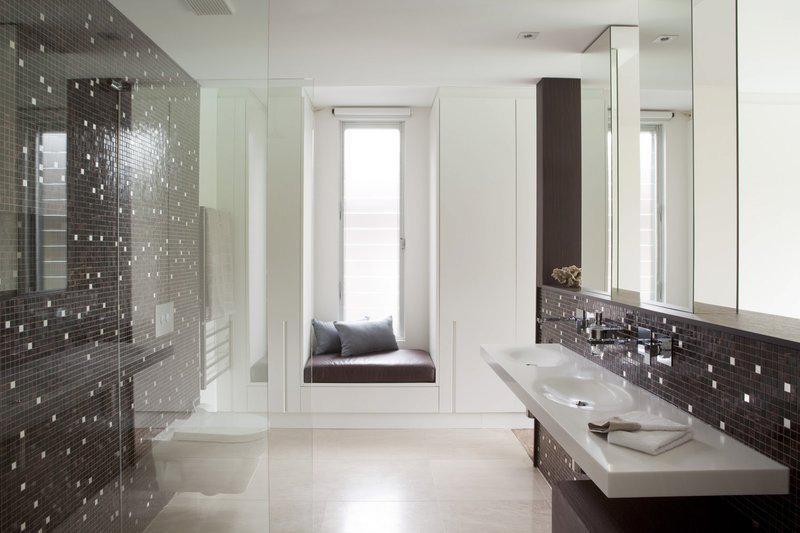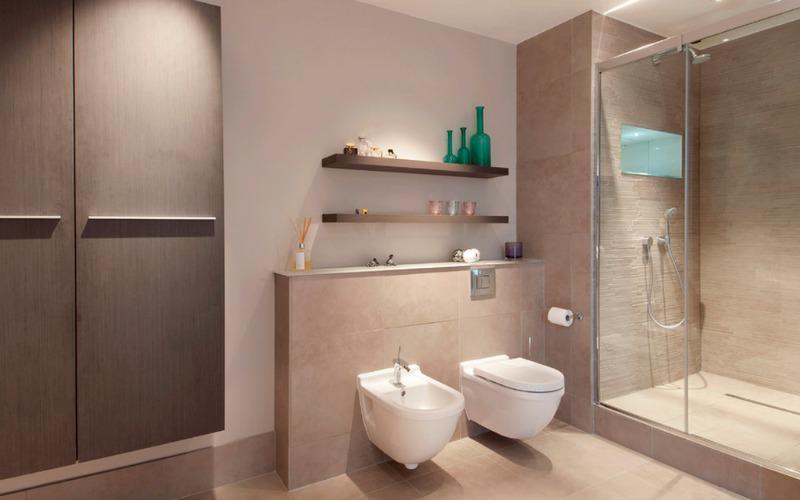The first image is the image on the left, the second image is the image on the right. Analyze the images presented: Is the assertion "One of the bathrooms features a shower but no bathtub." valid? Answer yes or no. Yes. The first image is the image on the left, the second image is the image on the right. Examine the images to the left and right. Is the description "There is a bide as well as a toilet in a bathroom with at least one shelf behind it" accurate? Answer yes or no. Yes. 